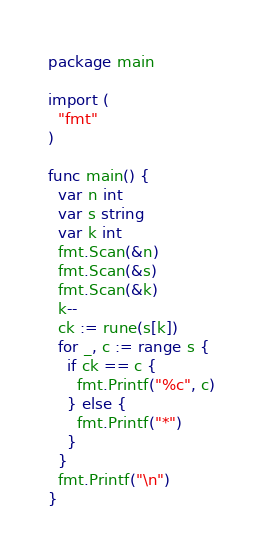<code> <loc_0><loc_0><loc_500><loc_500><_Go_>package main

import (
  "fmt"
)

func main() {
  var n int
  var s string
  var k int
  fmt.Scan(&n)
  fmt.Scan(&s)
  fmt.Scan(&k)
  k--
  ck := rune(s[k])
  for _, c := range s {
    if ck == c {
      fmt.Printf("%c", c)
    } else {
      fmt.Printf("*")
    }
  }
  fmt.Printf("\n")
}
</code> 